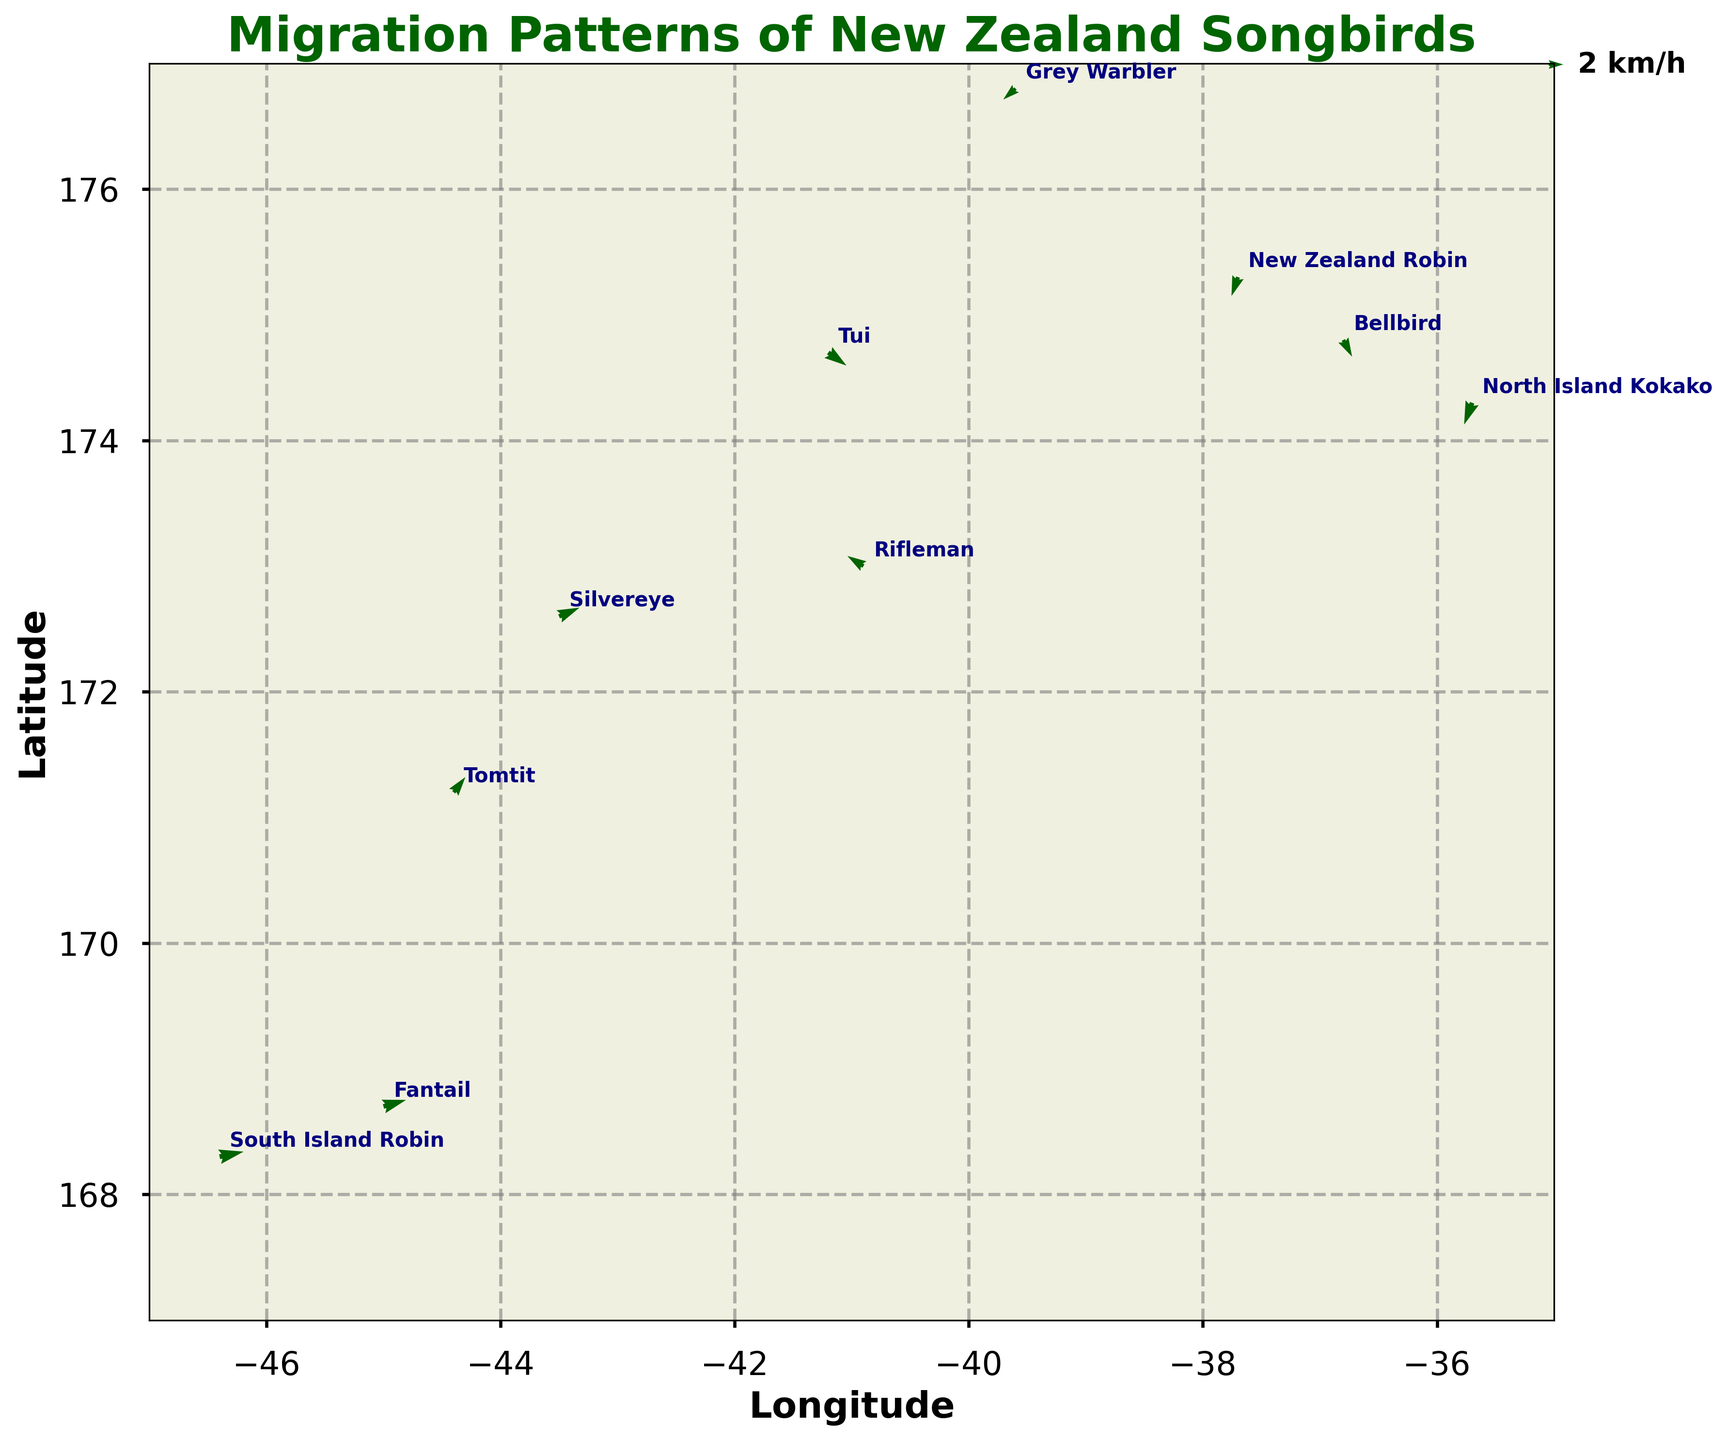What is the title of the quiver plot? The title of the quiver plot is shown at the top of the figure.
Answer: Migration Patterns of New Zealand Songbirds How many different species are represented on the quiver plot? Each species is labeled next to the corresponding point on the plot. Counting these labels gives the total number of species.
Answer: 10 Which species shows the least amount of directional change based on the length of its arrow? The species with the smallest arrow length represents the least amount of directional change. Checking each arrow, the New Zealand Robin has the shortest arrow.
Answer: New Zealand Robin What is the latitude and longitude of the South Island Robin? The position of each species is marked with a label. The South Island Robin is at the coordinates (-46.4, 168.3).
Answer: -46.4, 168.3 Which species exhibits the most downward migration? Analyzing the vertical component (v) of the arrows for each species, the species with the largest negative value of v shows the most downward migration. North Island Kokako has the greatest negative v (-3.0).
Answer: North Island Kokako Compare the migration direction of the Tui and Grey Warbler. How do they differ? The Tui moves southeast while the Grey Warbler moves southwest. Comparing their vertical (v) and horizontal (u) components: Tui (u=2.5, v=-1.8) and Grey Warbler (u=-1.7, v=-1.5). Tui moves right and down; Grey Warbler moves left and down.
Answer: Tui southeast, Grey Warbler southwest Which species has a directional movement northward? A positive vertical component (v) indicates northward movement. Check the arrows to find positive values. The Silvereye has v=1.2 and Tomtit has v=2.1, so both move northward.
Answer: Silvereye and Tomtit Calculate the average longitude position of all species. Sum all the longitude values and divide by the number of species, (−41.2 − 36.8 − 45.0 − 39.6 − 43.5 − 37.7 − 44.4 − 40.9 − 46.4 − 35.7) / 10 = -41.12.
Answer: -41.12 Compare the horizontal components (u) of Tui and Fantail. Which one moves more eastward? The species with the larger positive value of the horizontal component (u) moves more eastward. Tui has u=2.5, while Fantail has u=3.1. Therefore, Fantail moves more eastward.
Answer: Fantail What is the average migration speed (considering both u and v components) of the species Silvereye and Tomtit? Calculate the magnitude of each vector √(u^2 + v^2), then average the speeds. For Silvereye: √(2.8^2 + 1.2^2) ≈ 3.04. For Tomtit: √(1.6^2 + 2.1^2) ≈ 2.62. Average speed is (3.04 + 2.62) / 2 ≈ 2.83.
Answer: 2.83 